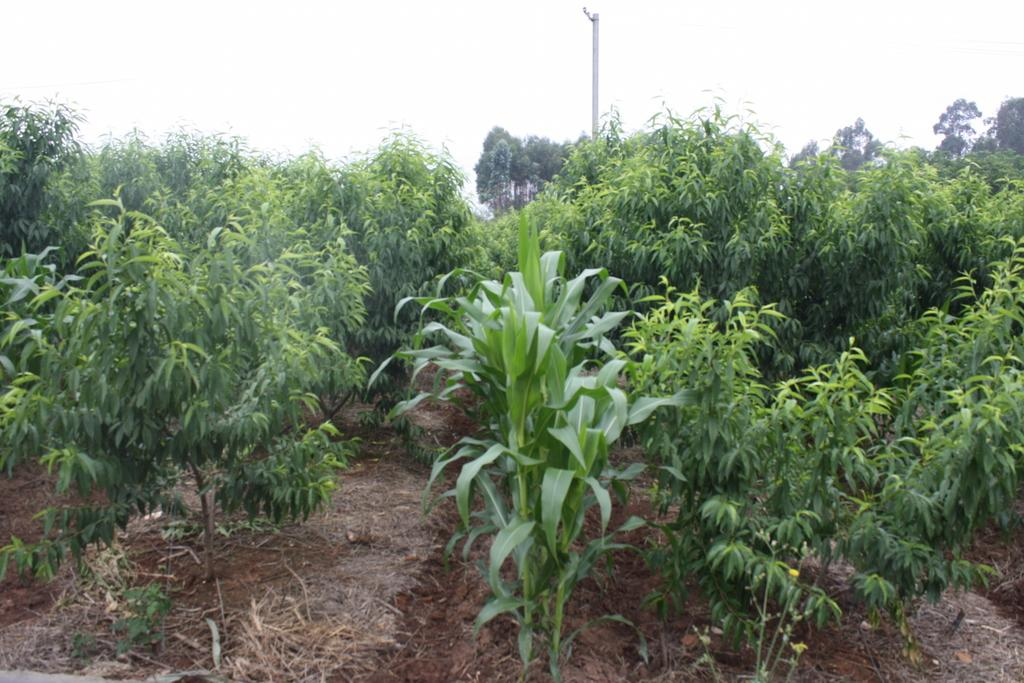What type of vegetation can be seen in the image? There are plants and trees in the image. Can you describe the pole in the middle of the image? Yes, there is a pole in the middle of the image. What else is present in the image besides plants, trees, and the pole? The provided facts do not mention any other objects or features in the image. What type of tin can be seen in the image? There is no tin present in the image. Can you tell me how many times your mom has visited this location? The provided facts do not mention any people or personal experiences, so we cannot answer this question. 